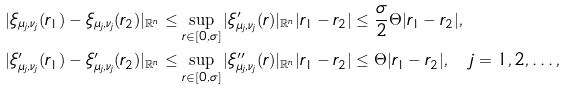Convert formula to latex. <formula><loc_0><loc_0><loc_500><loc_500>| \xi _ { \mu _ { j } , \nu _ { j } } ( r _ { 1 } ) - \xi _ { \mu _ { j } , \nu _ { j } } ( r _ { 2 } ) | _ { \mathbb { R } ^ { n } } & \leq \sup _ { r \in [ 0 , \sigma ] } | \xi _ { \mu _ { j } , \nu _ { j } } ^ { \prime } ( r ) | _ { \mathbb { R } ^ { n } } | r _ { 1 } - r _ { 2 } | \leq \frac { \sigma } { 2 } \Theta | r _ { 1 } - r _ { 2 } | , \\ | \xi _ { \mu _ { j } , \nu _ { j } } ^ { \prime } ( r _ { 1 } ) - \xi _ { \mu _ { j } , \nu _ { j } } ^ { \prime } ( r _ { 2 } ) | _ { \mathbb { R } ^ { n } } & \leq \sup _ { r \in [ 0 , \sigma ] } | \xi _ { \mu _ { j } , \nu _ { j } } ^ { \prime \prime } ( r ) | _ { \mathbb { R } ^ { n } } | r _ { 1 } - r _ { 2 } | \leq \Theta | r _ { 1 } - r _ { 2 } | , \quad j = 1 , 2 , \dots ,</formula> 